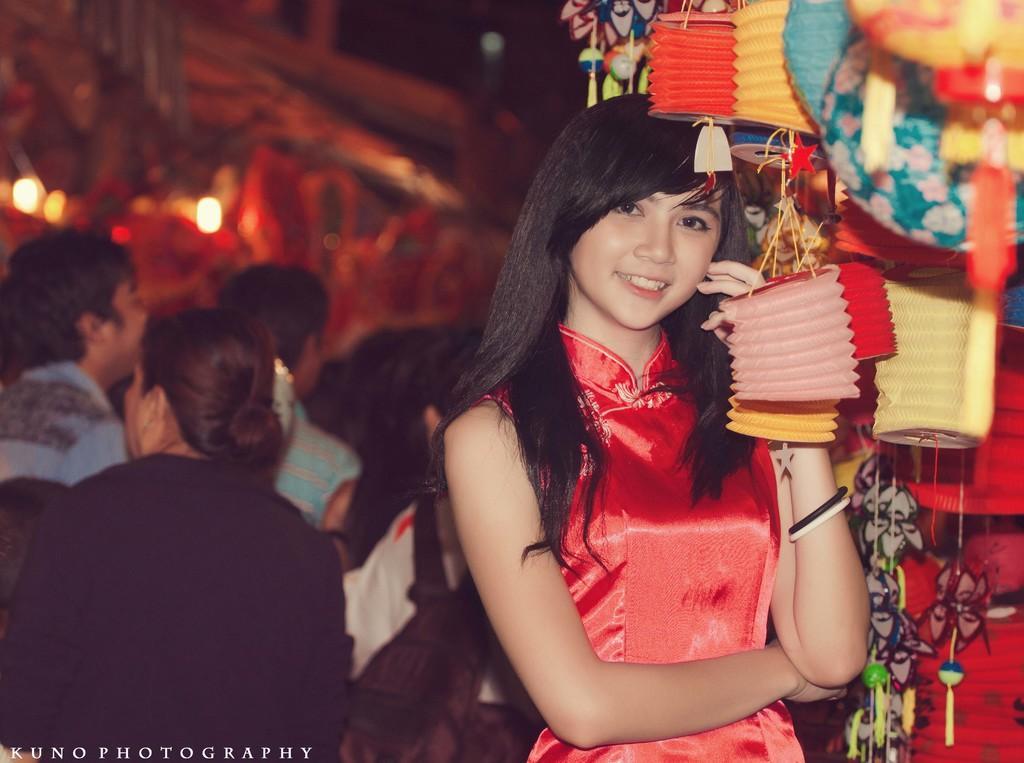Please provide a concise description of this image. In this image, there are group of people wearing clothes. There are decors in the top right of the image. 